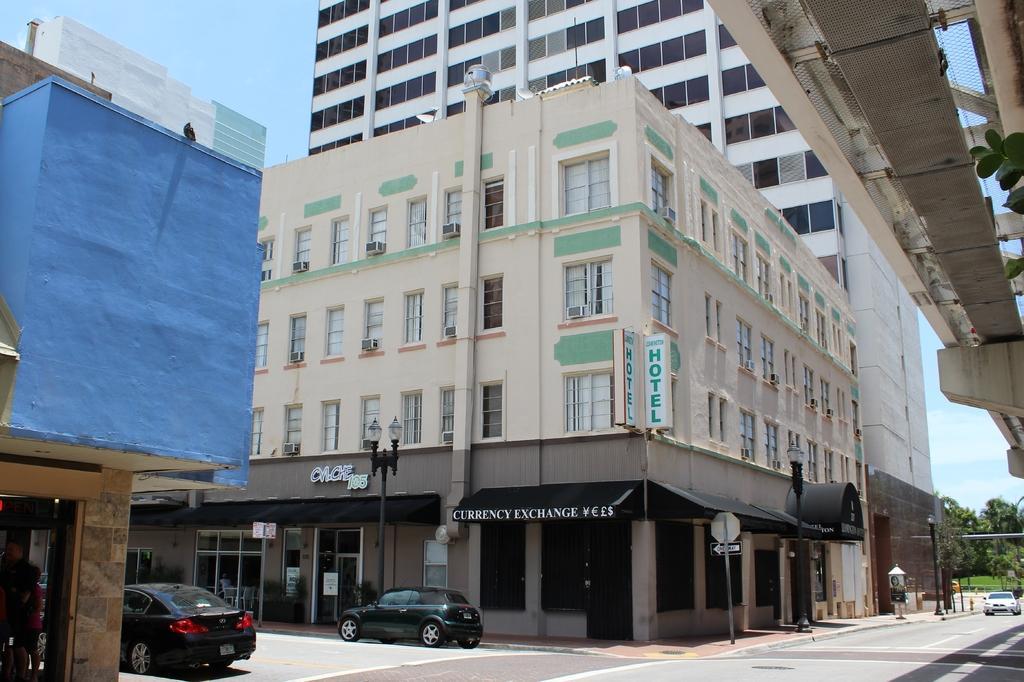In one or two sentences, can you explain what this image depicts? In this picture we can see some buildings here, there are two cars here, on the left side there is a person standing here, we can see a pole and lights here, there is a board here, we can see a hoarding here, there is the sky at the left top of the picture, we can see some trees here. 